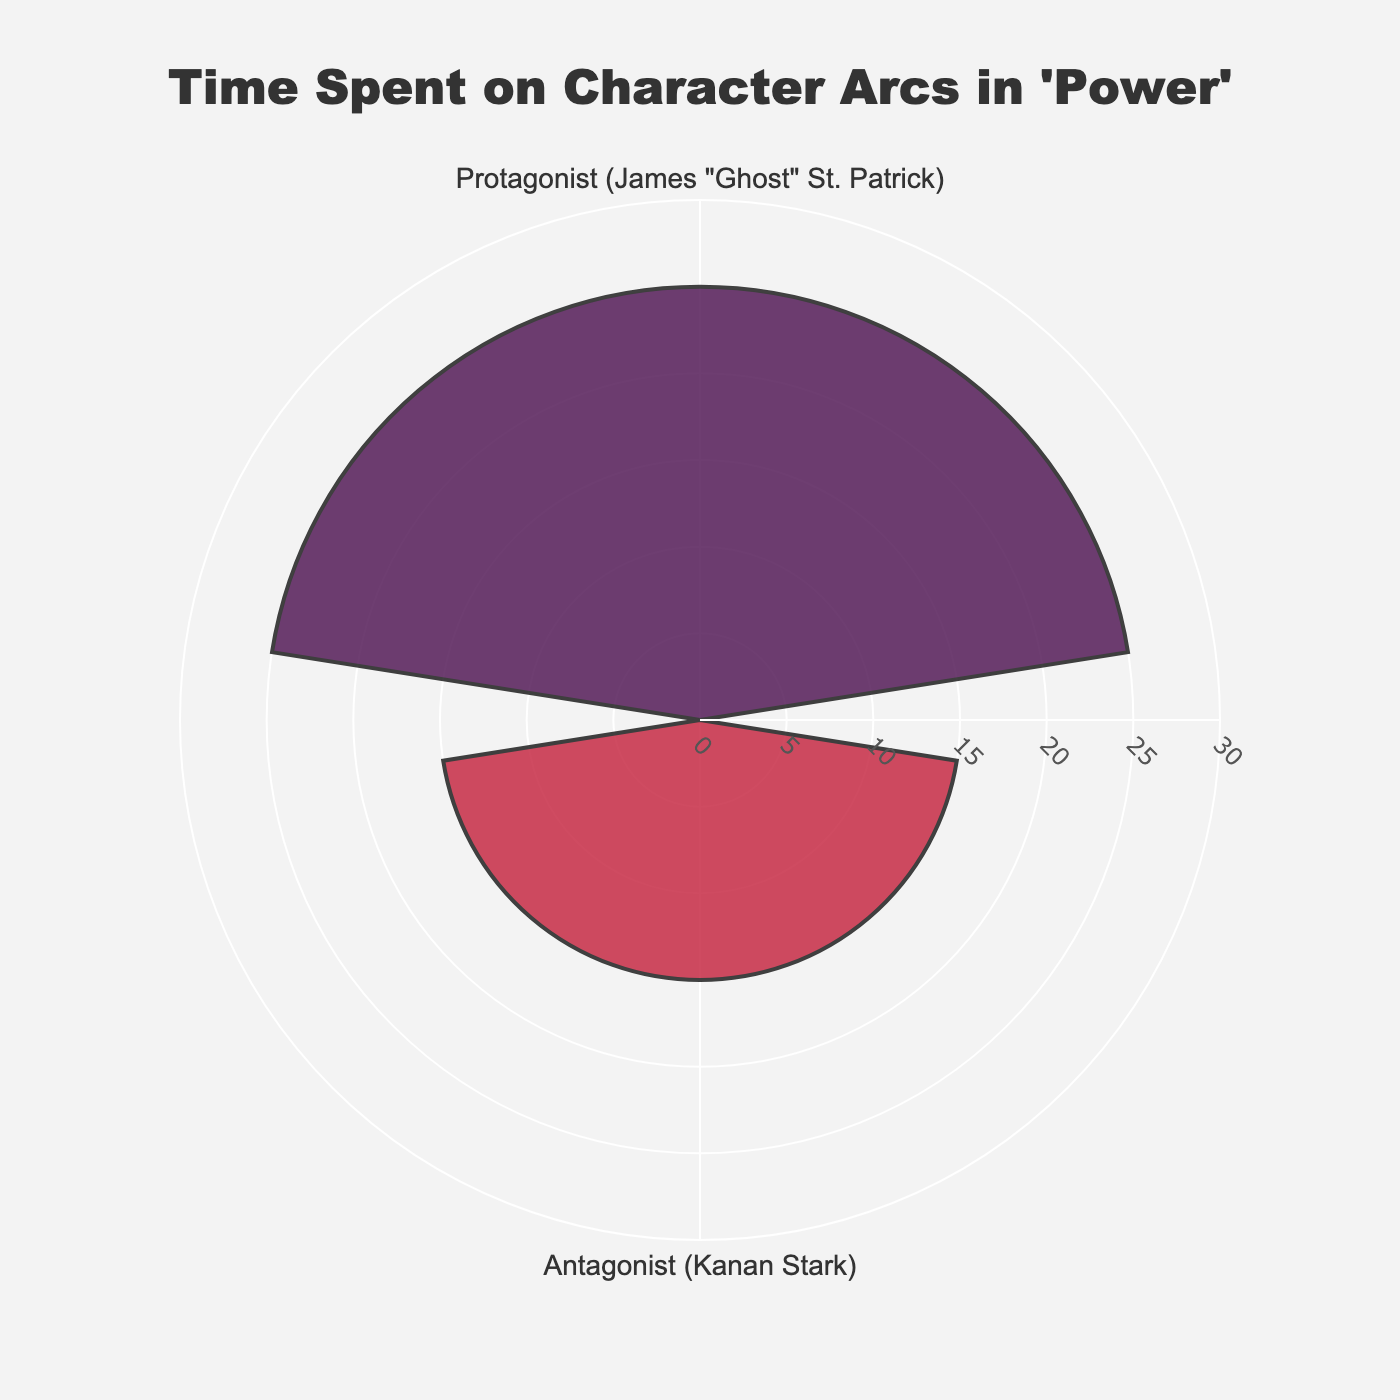What's the title of the chart? The title can be found at the top-center of the chart. It usually gives an overview of what the chart is depicting.
Answer: Time Spent on Character Arcs in 'Power' How many character arcs are represented in the chart? By counting the number of distinct color segments and labels around the radial axis, the number of character arcs can be identified.
Answer: 2 Which character arc has more screen time? By comparing the radial lengths, you can see which segment extends further from the center. The one with the longer radial line has more screen time.
Answer: Protagonist (James "Ghost" St. Patrick) What is the screen time of the antagonist character arc? Refer to the label and radial axis line corresponding to the antagonist character arc. The label indicates the screen time.
Answer: 15 hours What is the difference in screen time between the protagonist and antagonist character arcs? Subtract the screen time of the antagonist from that of the protagonist: 25 hours - 15 hours = 10 hours.
Answer: 10 hours If the screen time is to be distributed equally, how many hours would each character arc have? Calculate the total screen time and divide by the number of character arcs: (25 hours + 15 hours) / 2 = 20 hours.
Answer: 20 hours Which segment color corresponds to the character Kanan Stark? Identify the color of the segment associated with the "Kanan Stark" label.
Answer: Red Which character arc has the maximum radial distance? Observe the segment that extends furthest out radially from the center.
Answer: Protagonist (James "Ghost" St. Patrick) What is the radial axis's range in the plot? By examining the radial axis annotations, one can identify the range, specifically the maximum value it spans to.
Answer: 0 to 30 hours 